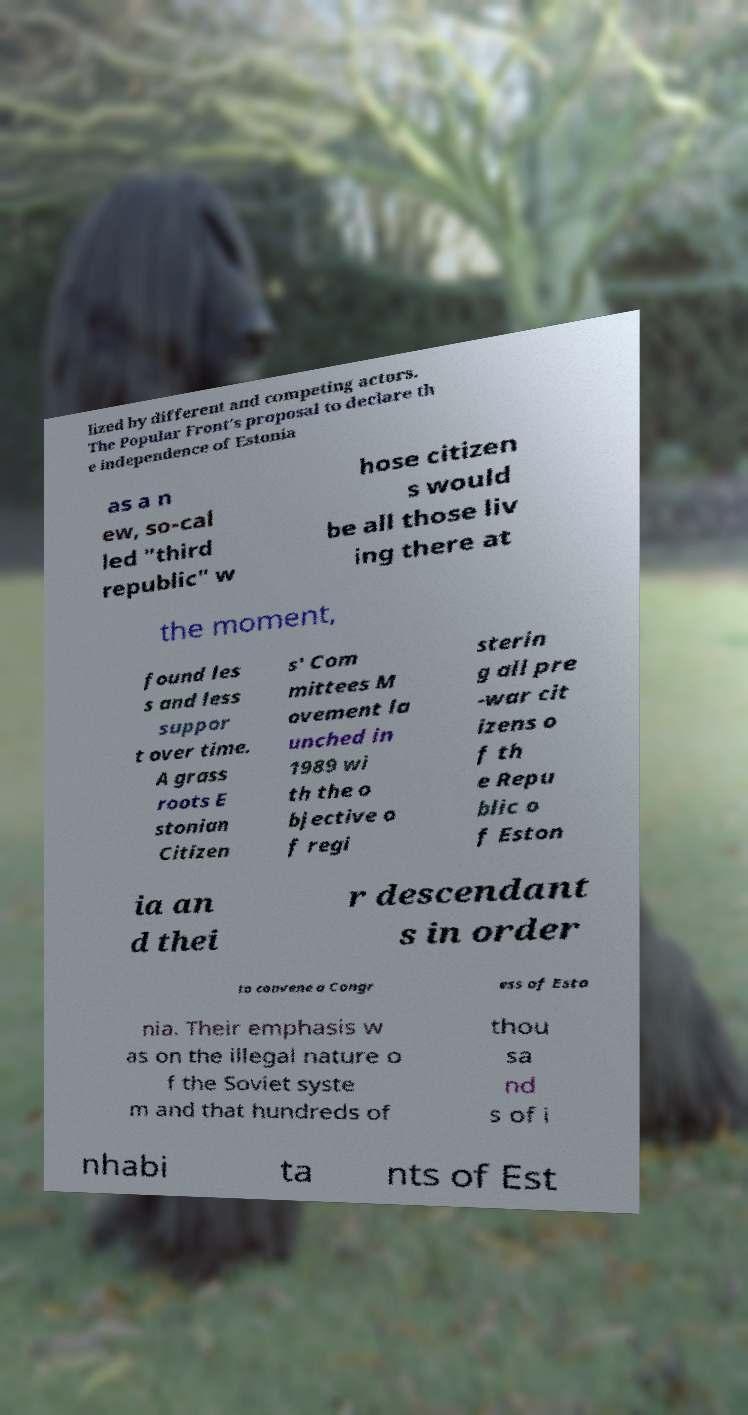I need the written content from this picture converted into text. Can you do that? lized by different and competing actors. The Popular Front's proposal to declare th e independence of Estonia as a n ew, so-cal led "third republic" w hose citizen s would be all those liv ing there at the moment, found les s and less suppor t over time. A grass roots E stonian Citizen s' Com mittees M ovement la unched in 1989 wi th the o bjective o f regi sterin g all pre -war cit izens o f th e Repu blic o f Eston ia an d thei r descendant s in order to convene a Congr ess of Esto nia. Their emphasis w as on the illegal nature o f the Soviet syste m and that hundreds of thou sa nd s of i nhabi ta nts of Est 